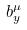<formula> <loc_0><loc_0><loc_500><loc_500>b _ { y } ^ { \mu }</formula> 